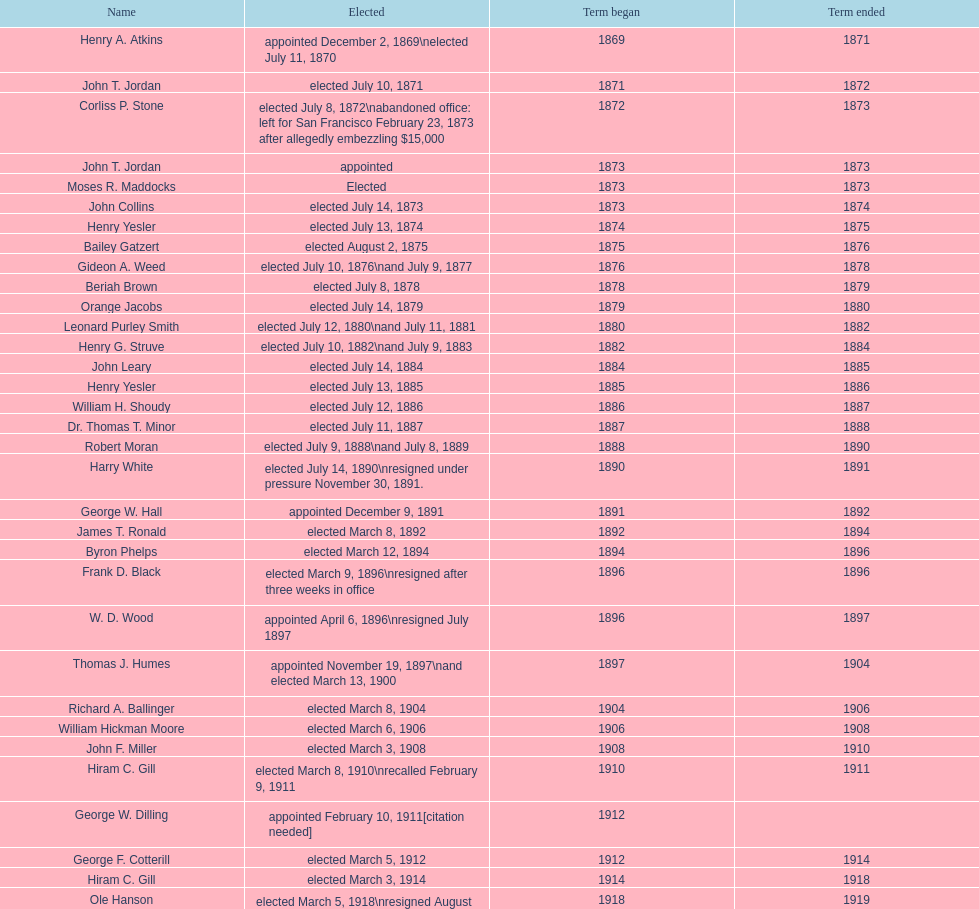Who began their term in 1890? Harry White. 